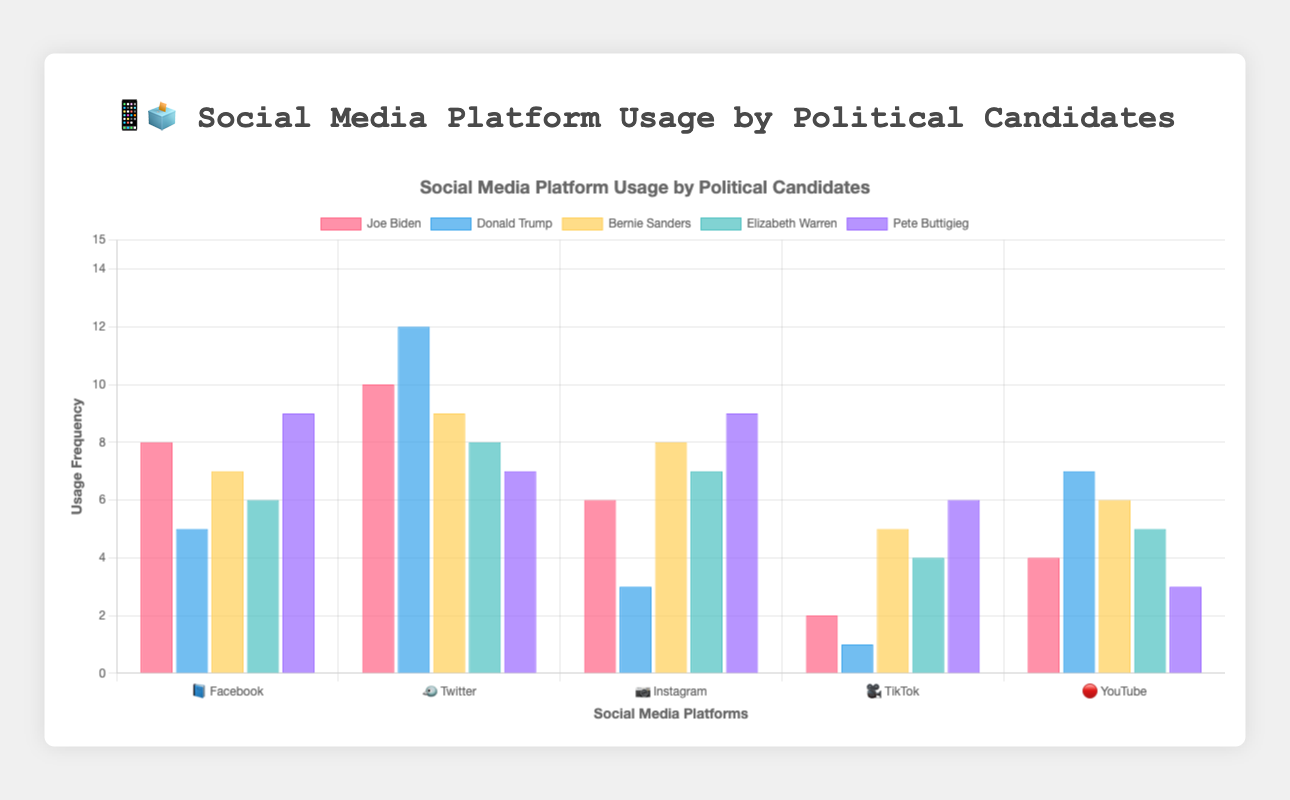What's the most frequently used social media platform by Joe Biden? By looking at Joe Biden's usage across all platforms, we see he used Twitter 10 times, Facebook 8 times, Instagram 6 times, YouTube 4 times, and TikTok 2 times. Therefore, Joe Biden uses Twitter the most.
Answer: Twitter Which candidate uses Instagram the most? By comparing the Instagram usage for each candidate, we see Pete Buttigieg uses it 9 times, Bernie Sanders uses it 8 times, Elizabeth Warren uses it 7 times, Joe Biden uses it 6 times, and Donald Trump uses it 3 times. Therefore, Pete Buttigieg uses Instagram the most.
Answer: Pete Buttigieg Who has the highest engagement rate on TikTok? By comparing the TikTok engagement rates, Pete Buttigieg has 3.2, Bernie Sanders has 2.8, Elizabeth Warren has 2.1, Joe Biden has 1.5, and Donald Trump has 0.9. Thus, Pete Buttigieg has the highest engagement rate on TikTok.
Answer: Pete Buttigieg Which candidate uses YouTube the least? By comparing the YouTube usage frequencies, Pete Buttigieg uses it 3 times, Joe Biden 4 times, Elizabeth Warren 5 times, Bernie Sanders 6 times, and Donald Trump 7 times. Hence, Pete Buttigieg uses YouTube the least.
Answer: Pete Buttigieg What's the total number of posts on Facebook by all candidates combined? Summing the Facebook usage frequencies: Joe Biden (8) + Donald Trump (5) + Bernie Sanders (7) + Elizabeth Warren (6) + Pete Buttigieg (9) = 35. Therefore, the total number of Facebook posts by all candidates is 35.
Answer: 35 Which social media platform has the highest combined engagement rate for all candidates? Adding the engagement rates for each platform: Facebook (3.2+4.8+3.9+3.5+4.1 = 19.5), Twitter (4.5+5.6+4.2+3.8+3.6 = 21.7), Instagram (2.8+2.2+3.6+3.2+4.3 = 16.1), TikTok (1.5+0.9+2.8+2.1+3.2 = 10.5), YouTube (2.1+3.7+2.5+2.3+1.8 = 12.4). Twitter has the highest combined engagement rate.
Answer: Twitter How many more times does Donald Trump use Twitter compared to Joe Biden? Donald Trump uses Twitter 12 times, whereas Joe Biden uses it 10 times. The difference is 12 - 10 = 2. Therefore, Donald Trump uses Twitter 2 more times than Joe Biden.
Answer: 2 Which candidate has the highest total engagement rate across all platforms? Adding each candidate's engagement rates: Joe Biden (3.2 + 4.5 + 2.8 + 1.5 + 2.1 = 14.1), Donald Trump (4.8 + 5.6 + 2.2 + 0.9 + 3.7 = 17.2), Bernie Sanders (3.9 + 4.2 + 3.6 + 2.8 + 2.5 = 17.0), Elizabeth Warren (3.5 + 3.8 + 3.2 + 2.1 + 2.3 = 14.9), Pete Buttigieg (4.1 + 3.6 + 4.3 + 3.2 + 1.8 = 17.0). Thus, Donald Trump has the highest total engagement rate.
Answer: Donald Trump 